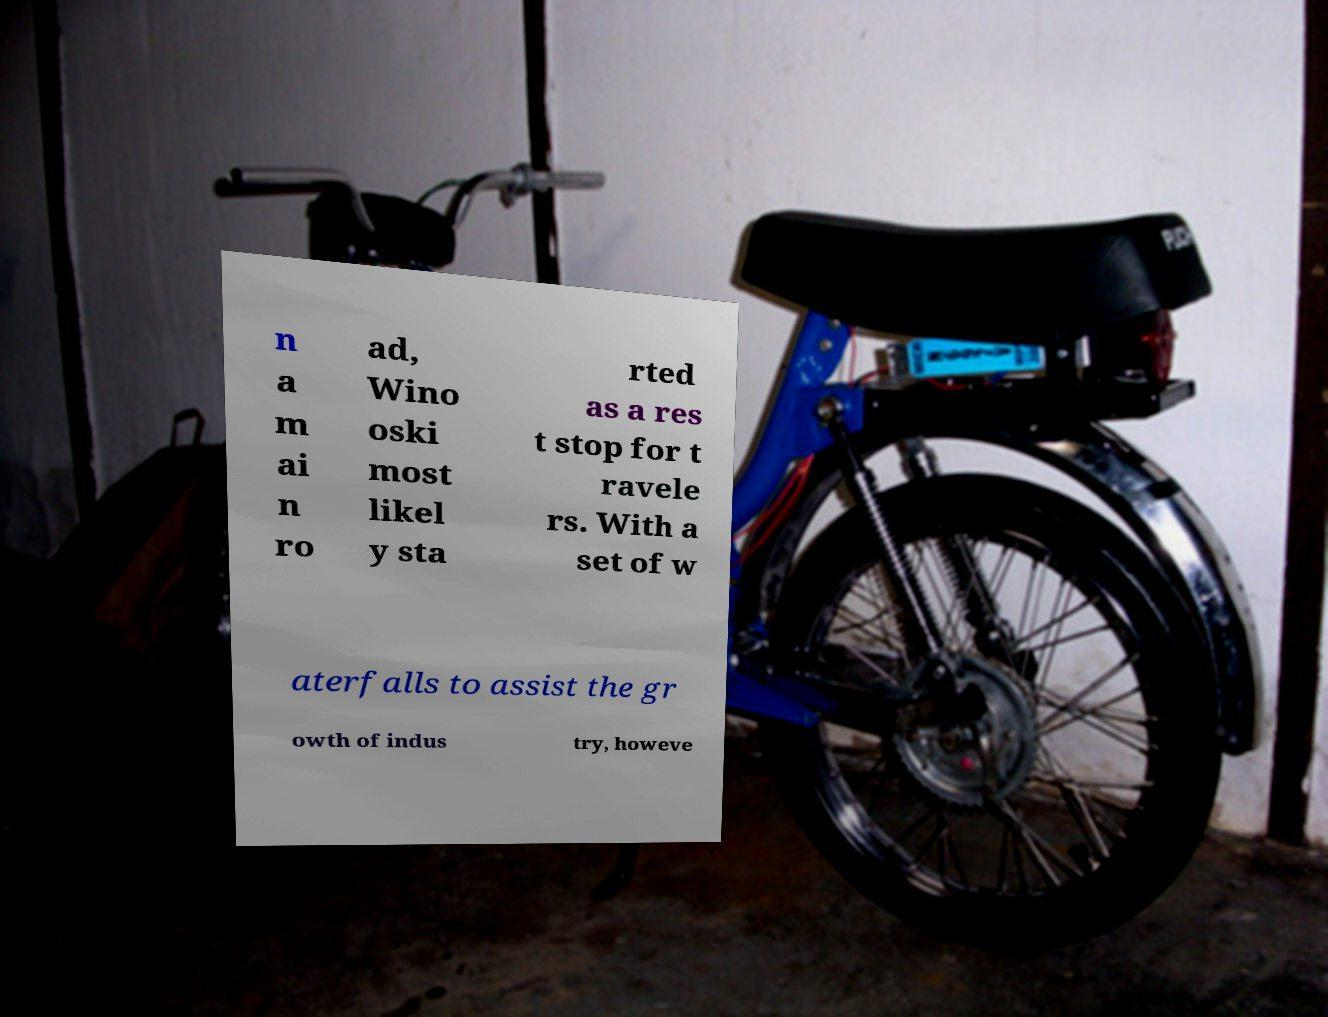Can you accurately transcribe the text from the provided image for me? n a m ai n ro ad, Wino oski most likel y sta rted as a res t stop for t ravele rs. With a set of w aterfalls to assist the gr owth of indus try, howeve 